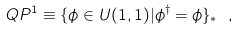Convert formula to latex. <formula><loc_0><loc_0><loc_500><loc_500>Q P ^ { 1 } \equiv \{ \phi \in U ( 1 , 1 ) | \phi ^ { \dag } = \phi \} _ { * } \ ,</formula> 